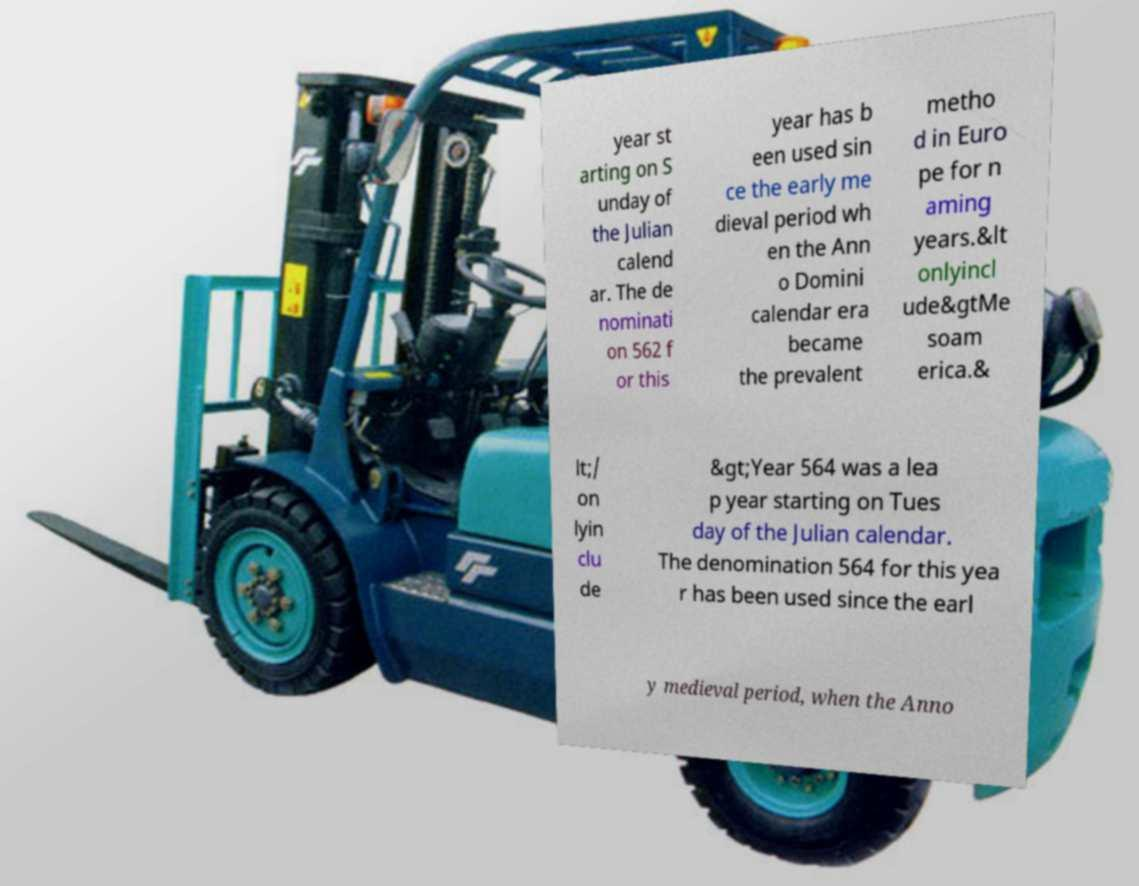What messages or text are displayed in this image? I need them in a readable, typed format. year st arting on S unday of the Julian calend ar. The de nominati on 562 f or this year has b een used sin ce the early me dieval period wh en the Ann o Domini calendar era became the prevalent metho d in Euro pe for n aming years.&lt onlyincl ude&gtMe soam erica.& lt;/ on lyin clu de &gt;Year 564 was a lea p year starting on Tues day of the Julian calendar. The denomination 564 for this yea r has been used since the earl y medieval period, when the Anno 